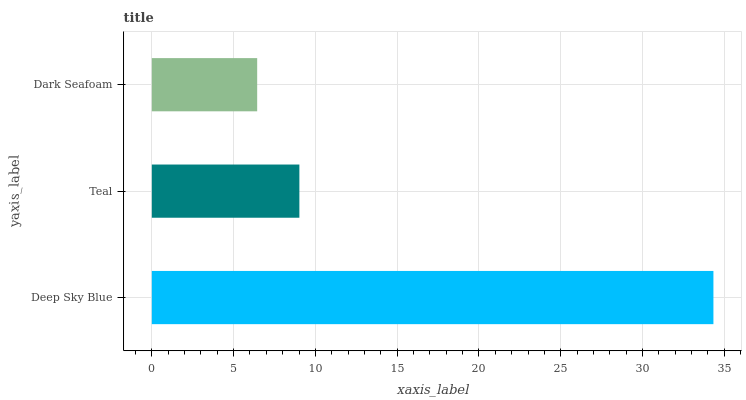Is Dark Seafoam the minimum?
Answer yes or no. Yes. Is Deep Sky Blue the maximum?
Answer yes or no. Yes. Is Teal the minimum?
Answer yes or no. No. Is Teal the maximum?
Answer yes or no. No. Is Deep Sky Blue greater than Teal?
Answer yes or no. Yes. Is Teal less than Deep Sky Blue?
Answer yes or no. Yes. Is Teal greater than Deep Sky Blue?
Answer yes or no. No. Is Deep Sky Blue less than Teal?
Answer yes or no. No. Is Teal the high median?
Answer yes or no. Yes. Is Teal the low median?
Answer yes or no. Yes. Is Deep Sky Blue the high median?
Answer yes or no. No. Is Deep Sky Blue the low median?
Answer yes or no. No. 